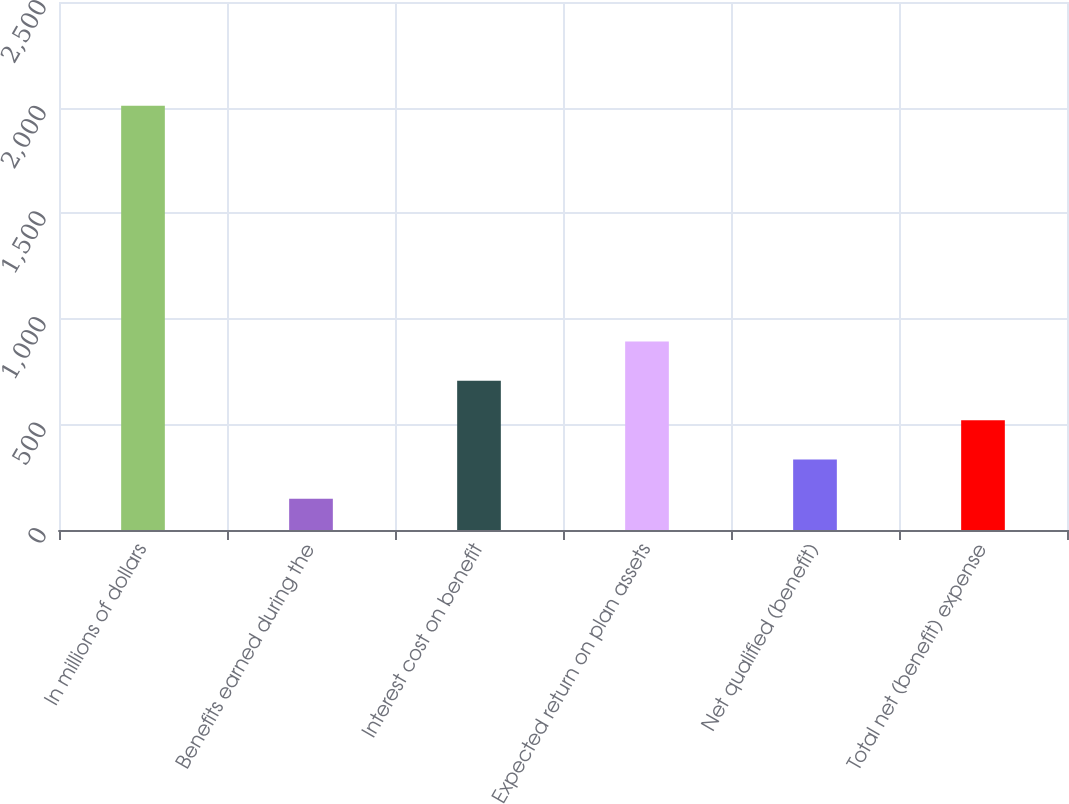Convert chart. <chart><loc_0><loc_0><loc_500><loc_500><bar_chart><fcel>In millions of dollars<fcel>Benefits earned during the<fcel>Interest cost on benefit<fcel>Expected return on plan assets<fcel>Net qualified (benefit)<fcel>Total net (benefit) expense<nl><fcel>2009<fcel>148<fcel>706.3<fcel>892.4<fcel>334.1<fcel>520.2<nl></chart> 